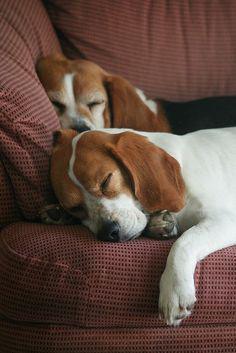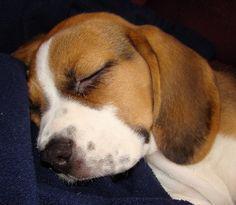The first image is the image on the left, the second image is the image on the right. Examine the images to the left and right. Is the description "The dogs are lying in the same direction." accurate? Answer yes or no. Yes. The first image is the image on the left, the second image is the image on the right. For the images displayed, is the sentence "At least one dog is curled up in a ball." factually correct? Answer yes or no. No. 